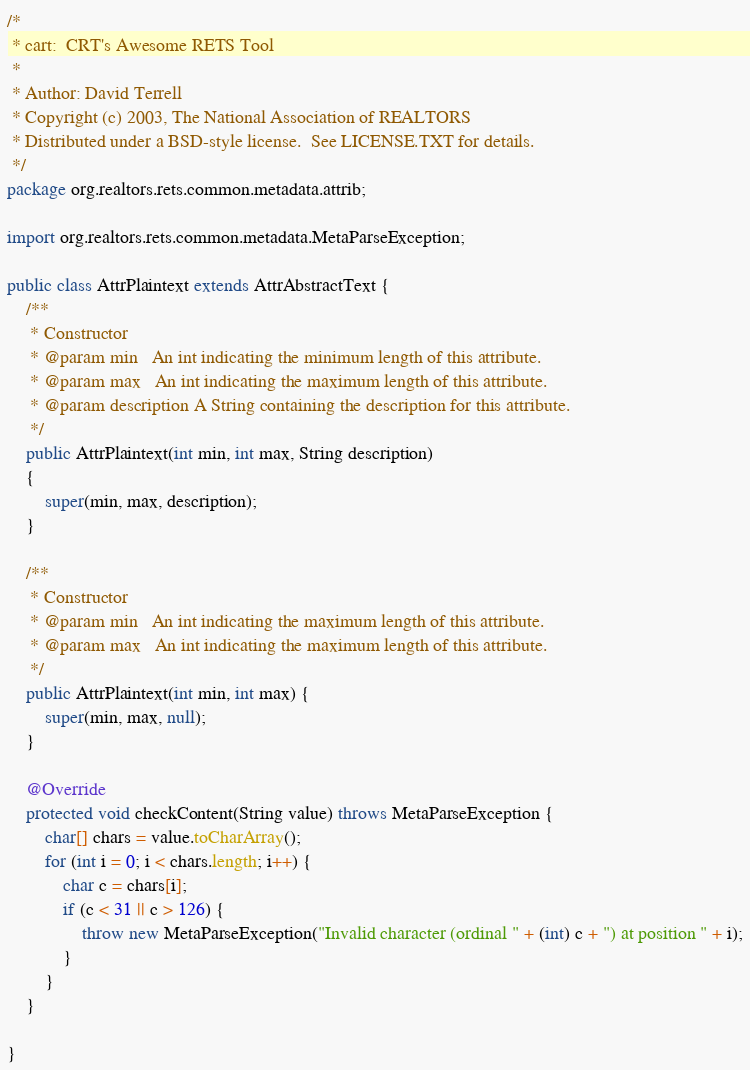Convert code to text. <code><loc_0><loc_0><loc_500><loc_500><_Java_>/*
 * cart:  CRT's Awesome RETS Tool
 *
 * Author: David Terrell
 * Copyright (c) 2003, The National Association of REALTORS
 * Distributed under a BSD-style license.  See LICENSE.TXT for details.
 */
package org.realtors.rets.common.metadata.attrib;

import org.realtors.rets.common.metadata.MetaParseException;

public class AttrPlaintext extends AttrAbstractText {
	/**
	 * Constructor
	 * @param min	An int indicating the minimum length of this attribute.
	 * @param max	An int indicating the maximum length of this attribute.
	 * @param description A String containing the description for this attribute.
	 */
	public AttrPlaintext(int min, int max, String description) 
	{
		super(min, max, description);
	}
	
	/**
	 * Constructor
	 * @param min	An int indicating the maximum length of this attribute.
	 * @param max	An int indicating the maximum length of this attribute.
	 */
	public AttrPlaintext(int min, int max) {
		super(min, max, null);
	}

	@Override
	protected void checkContent(String value) throws MetaParseException {
		char[] chars = value.toCharArray();
		for (int i = 0; i < chars.length; i++) {
			char c = chars[i];
			if (c < 31 || c > 126) {
				throw new MetaParseException("Invalid character (ordinal " + (int) c + ") at position " + i);
			}
		}
	}

}
</code> 